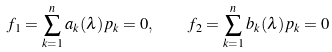<formula> <loc_0><loc_0><loc_500><loc_500>f _ { 1 } = \sum _ { k = 1 } ^ { n } a _ { k } ( \lambda ) p _ { k } = 0 , \quad f _ { 2 } = \sum _ { k = 1 } ^ { n } b _ { k } ( \lambda ) p _ { k } = 0</formula> 